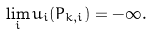Convert formula to latex. <formula><loc_0><loc_0><loc_500><loc_500>\lim _ { i } u _ { i } ( P _ { k , i } ) = - \infty .</formula> 